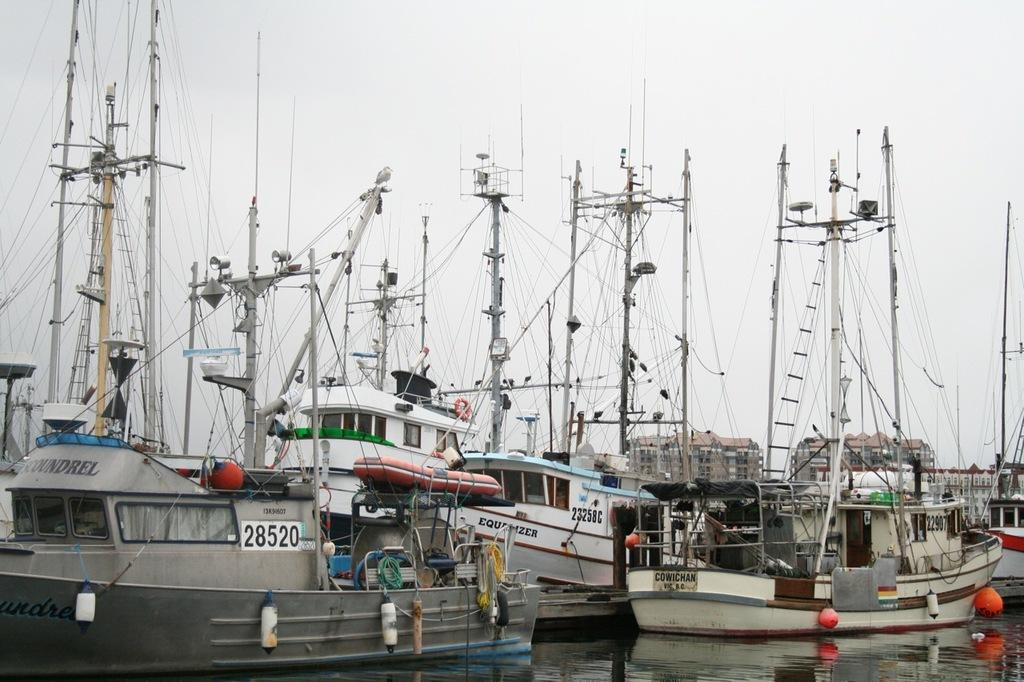What is the main subject of the image? The main subject of the image is many boats. Where are the boats located? The boats are on the water. What can be seen in the background of the image? There is a sky visible in the background of the image. What type of berry can be seen growing on the boats in the image? There are no berries present on the boats in the image. How many stitches are required to repair the sails of the boats in the image? There is no information about the sails or any need for repair in the image. 